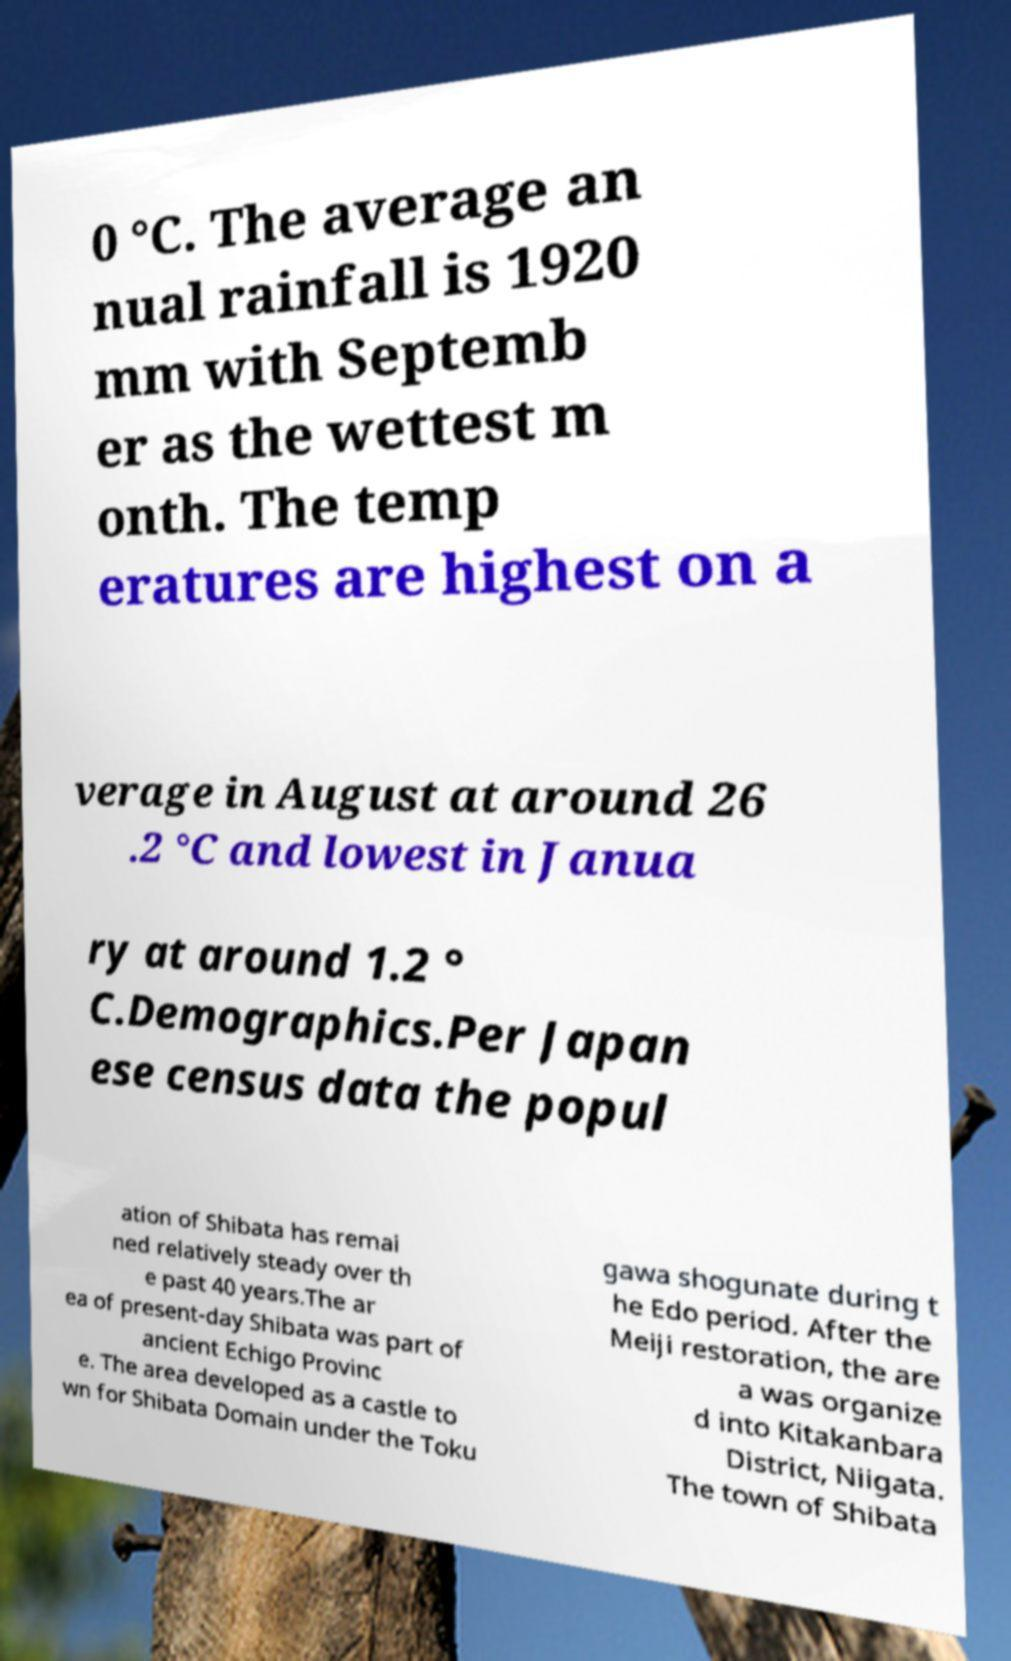What messages or text are displayed in this image? I need them in a readable, typed format. 0 °C. The average an nual rainfall is 1920 mm with Septemb er as the wettest m onth. The temp eratures are highest on a verage in August at around 26 .2 °C and lowest in Janua ry at around 1.2 ° C.Demographics.Per Japan ese census data the popul ation of Shibata has remai ned relatively steady over th e past 40 years.The ar ea of present-day Shibata was part of ancient Echigo Provinc e. The area developed as a castle to wn for Shibata Domain under the Toku gawa shogunate during t he Edo period. After the Meiji restoration, the are a was organize d into Kitakanbara District, Niigata. The town of Shibata 